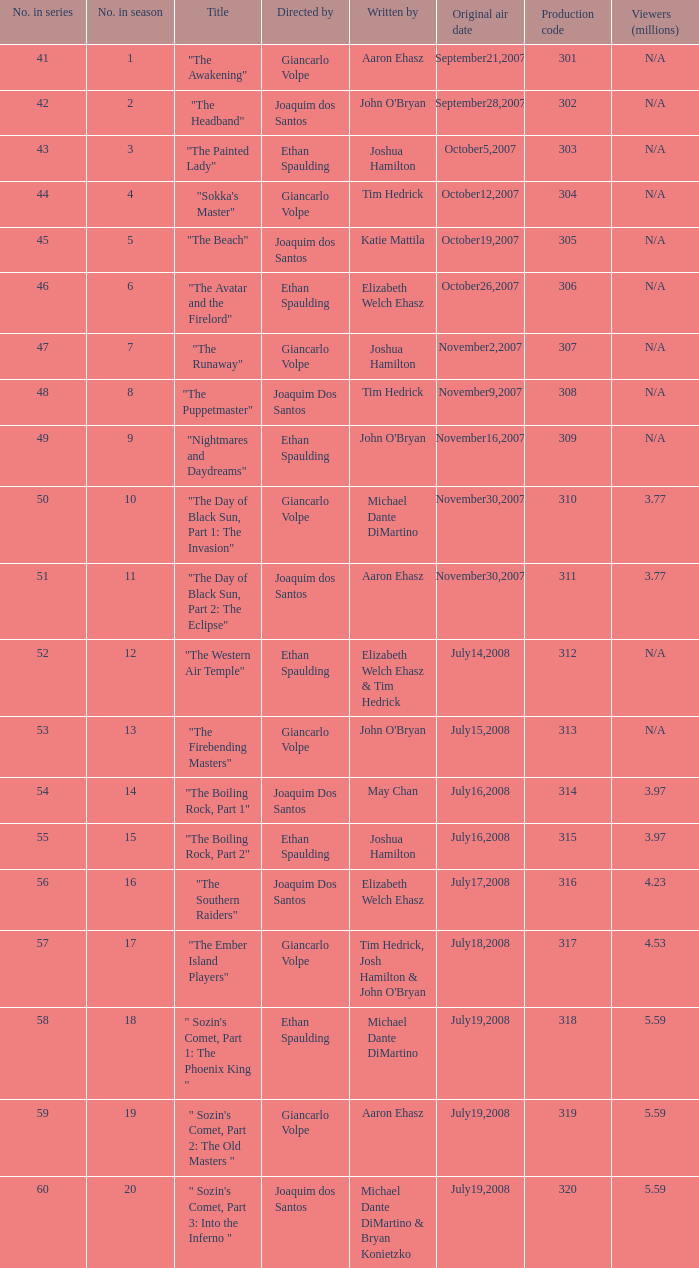What is the original air date for the episode with a production code of 318? July19,2008. 